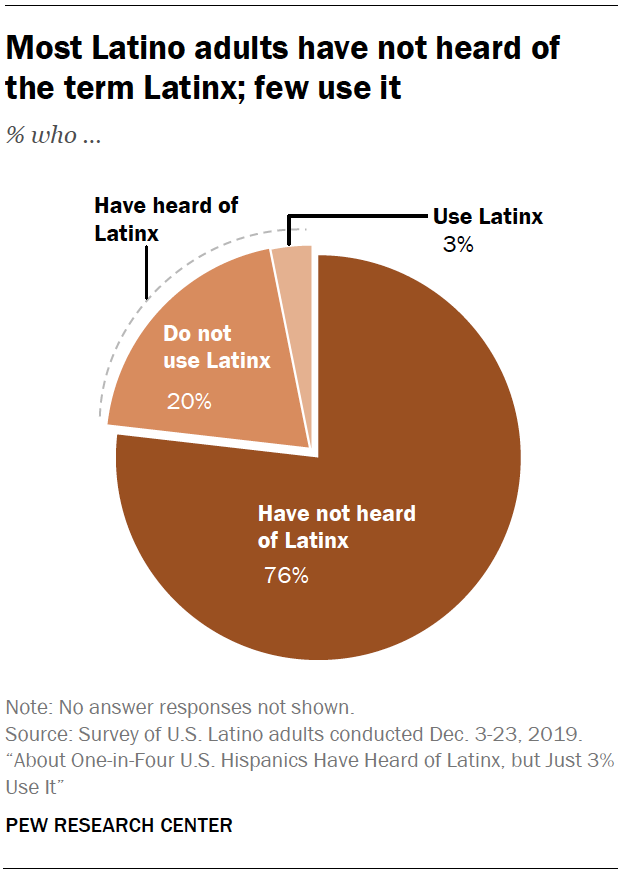How might the data on the 'Latinx' term awareness and usage potentially impact linguistic trends and policies? The data suggests that 'Latinx' is not widely used among Latino adults, which may influence the adoption of the term in media, academia, and policy-making. If policymakers and institutions aim to be inclusive while also reflecting the preferences of the community, they may need to consider these findings and explore alternative terms or approaches that resonate more with the community's collective identity. 